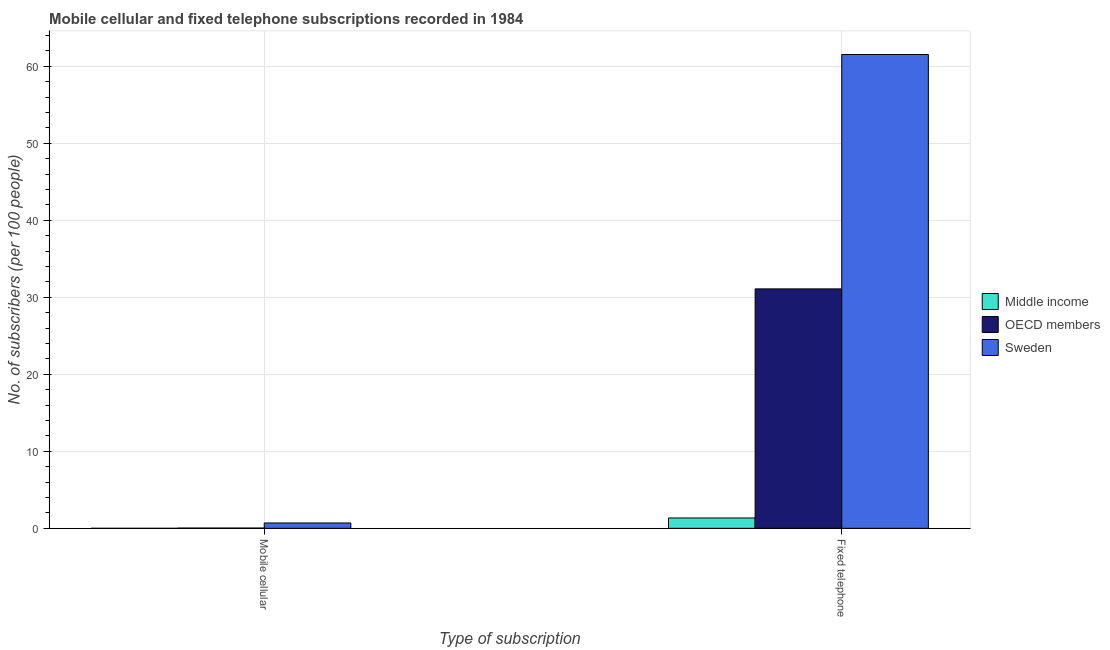How many bars are there on the 1st tick from the right?
Make the answer very short. 3. What is the label of the 2nd group of bars from the left?
Your response must be concise. Fixed telephone. What is the number of fixed telephone subscribers in Middle income?
Provide a succinct answer. 1.34. Across all countries, what is the maximum number of mobile cellular subscribers?
Make the answer very short. 0.69. Across all countries, what is the minimum number of fixed telephone subscribers?
Provide a succinct answer. 1.34. What is the total number of mobile cellular subscribers in the graph?
Ensure brevity in your answer.  0.73. What is the difference between the number of mobile cellular subscribers in OECD members and that in Middle income?
Offer a very short reply. 0.03. What is the difference between the number of mobile cellular subscribers in OECD members and the number of fixed telephone subscribers in Sweden?
Provide a short and direct response. -61.49. What is the average number of mobile cellular subscribers per country?
Ensure brevity in your answer.  0.24. What is the difference between the number of mobile cellular subscribers and number of fixed telephone subscribers in Sweden?
Your response must be concise. -60.83. In how many countries, is the number of mobile cellular subscribers greater than 22 ?
Ensure brevity in your answer.  0. What is the ratio of the number of fixed telephone subscribers in Sweden to that in Middle income?
Make the answer very short. 45.78. In how many countries, is the number of fixed telephone subscribers greater than the average number of fixed telephone subscribers taken over all countries?
Your response must be concise. 1. What does the 1st bar from the left in Fixed telephone represents?
Keep it short and to the point. Middle income. How many bars are there?
Your answer should be compact. 6. What is the difference between two consecutive major ticks on the Y-axis?
Your response must be concise. 10. Does the graph contain any zero values?
Offer a terse response. No. Does the graph contain grids?
Offer a very short reply. Yes. How many legend labels are there?
Ensure brevity in your answer.  3. What is the title of the graph?
Keep it short and to the point. Mobile cellular and fixed telephone subscriptions recorded in 1984. What is the label or title of the X-axis?
Your response must be concise. Type of subscription. What is the label or title of the Y-axis?
Keep it short and to the point. No. of subscribers (per 100 people). What is the No. of subscribers (per 100 people) of Middle income in Mobile cellular?
Make the answer very short. 5.23702945543217e-5. What is the No. of subscribers (per 100 people) of OECD members in Mobile cellular?
Provide a short and direct response. 0.03. What is the No. of subscribers (per 100 people) of Sweden in Mobile cellular?
Provide a short and direct response. 0.69. What is the No. of subscribers (per 100 people) in Middle income in Fixed telephone?
Your response must be concise. 1.34. What is the No. of subscribers (per 100 people) in OECD members in Fixed telephone?
Offer a very short reply. 31.09. What is the No. of subscribers (per 100 people) of Sweden in Fixed telephone?
Give a very brief answer. 61.53. Across all Type of subscription, what is the maximum No. of subscribers (per 100 people) of Middle income?
Make the answer very short. 1.34. Across all Type of subscription, what is the maximum No. of subscribers (per 100 people) of OECD members?
Provide a short and direct response. 31.09. Across all Type of subscription, what is the maximum No. of subscribers (per 100 people) in Sweden?
Offer a very short reply. 61.53. Across all Type of subscription, what is the minimum No. of subscribers (per 100 people) in Middle income?
Offer a terse response. 5.23702945543217e-5. Across all Type of subscription, what is the minimum No. of subscribers (per 100 people) in OECD members?
Offer a very short reply. 0.03. Across all Type of subscription, what is the minimum No. of subscribers (per 100 people) of Sweden?
Offer a very short reply. 0.69. What is the total No. of subscribers (per 100 people) of Middle income in the graph?
Offer a very short reply. 1.34. What is the total No. of subscribers (per 100 people) in OECD members in the graph?
Your answer should be compact. 31.13. What is the total No. of subscribers (per 100 people) of Sweden in the graph?
Provide a succinct answer. 62.22. What is the difference between the No. of subscribers (per 100 people) of Middle income in Mobile cellular and that in Fixed telephone?
Your response must be concise. -1.34. What is the difference between the No. of subscribers (per 100 people) in OECD members in Mobile cellular and that in Fixed telephone?
Give a very brief answer. -31.06. What is the difference between the No. of subscribers (per 100 people) of Sweden in Mobile cellular and that in Fixed telephone?
Provide a succinct answer. -60.83. What is the difference between the No. of subscribers (per 100 people) of Middle income in Mobile cellular and the No. of subscribers (per 100 people) of OECD members in Fixed telephone?
Ensure brevity in your answer.  -31.09. What is the difference between the No. of subscribers (per 100 people) in Middle income in Mobile cellular and the No. of subscribers (per 100 people) in Sweden in Fixed telephone?
Provide a short and direct response. -61.53. What is the difference between the No. of subscribers (per 100 people) in OECD members in Mobile cellular and the No. of subscribers (per 100 people) in Sweden in Fixed telephone?
Keep it short and to the point. -61.49. What is the average No. of subscribers (per 100 people) in Middle income per Type of subscription?
Offer a terse response. 0.67. What is the average No. of subscribers (per 100 people) in OECD members per Type of subscription?
Give a very brief answer. 15.56. What is the average No. of subscribers (per 100 people) in Sweden per Type of subscription?
Ensure brevity in your answer.  31.11. What is the difference between the No. of subscribers (per 100 people) in Middle income and No. of subscribers (per 100 people) in OECD members in Mobile cellular?
Give a very brief answer. -0.03. What is the difference between the No. of subscribers (per 100 people) of Middle income and No. of subscribers (per 100 people) of Sweden in Mobile cellular?
Make the answer very short. -0.69. What is the difference between the No. of subscribers (per 100 people) in OECD members and No. of subscribers (per 100 people) in Sweden in Mobile cellular?
Offer a very short reply. -0.66. What is the difference between the No. of subscribers (per 100 people) in Middle income and No. of subscribers (per 100 people) in OECD members in Fixed telephone?
Provide a succinct answer. -29.75. What is the difference between the No. of subscribers (per 100 people) in Middle income and No. of subscribers (per 100 people) in Sweden in Fixed telephone?
Provide a succinct answer. -60.18. What is the difference between the No. of subscribers (per 100 people) in OECD members and No. of subscribers (per 100 people) in Sweden in Fixed telephone?
Ensure brevity in your answer.  -30.43. What is the ratio of the No. of subscribers (per 100 people) of Middle income in Mobile cellular to that in Fixed telephone?
Your response must be concise. 0. What is the ratio of the No. of subscribers (per 100 people) in OECD members in Mobile cellular to that in Fixed telephone?
Give a very brief answer. 0. What is the ratio of the No. of subscribers (per 100 people) in Sweden in Mobile cellular to that in Fixed telephone?
Your answer should be very brief. 0.01. What is the difference between the highest and the second highest No. of subscribers (per 100 people) in Middle income?
Your answer should be very brief. 1.34. What is the difference between the highest and the second highest No. of subscribers (per 100 people) in OECD members?
Provide a short and direct response. 31.06. What is the difference between the highest and the second highest No. of subscribers (per 100 people) of Sweden?
Your answer should be compact. 60.83. What is the difference between the highest and the lowest No. of subscribers (per 100 people) of Middle income?
Your answer should be compact. 1.34. What is the difference between the highest and the lowest No. of subscribers (per 100 people) of OECD members?
Provide a succinct answer. 31.06. What is the difference between the highest and the lowest No. of subscribers (per 100 people) in Sweden?
Make the answer very short. 60.83. 